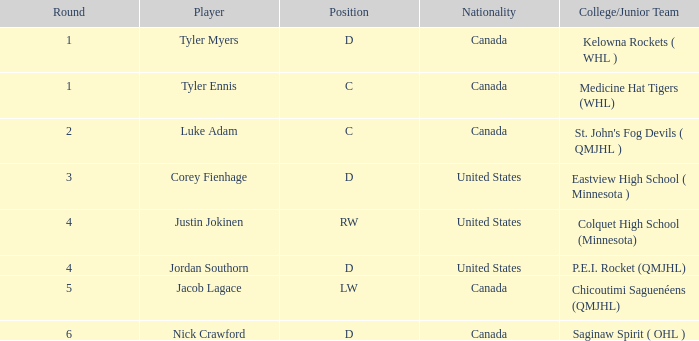What is the total of the selection of the lw position player? 134.0. 